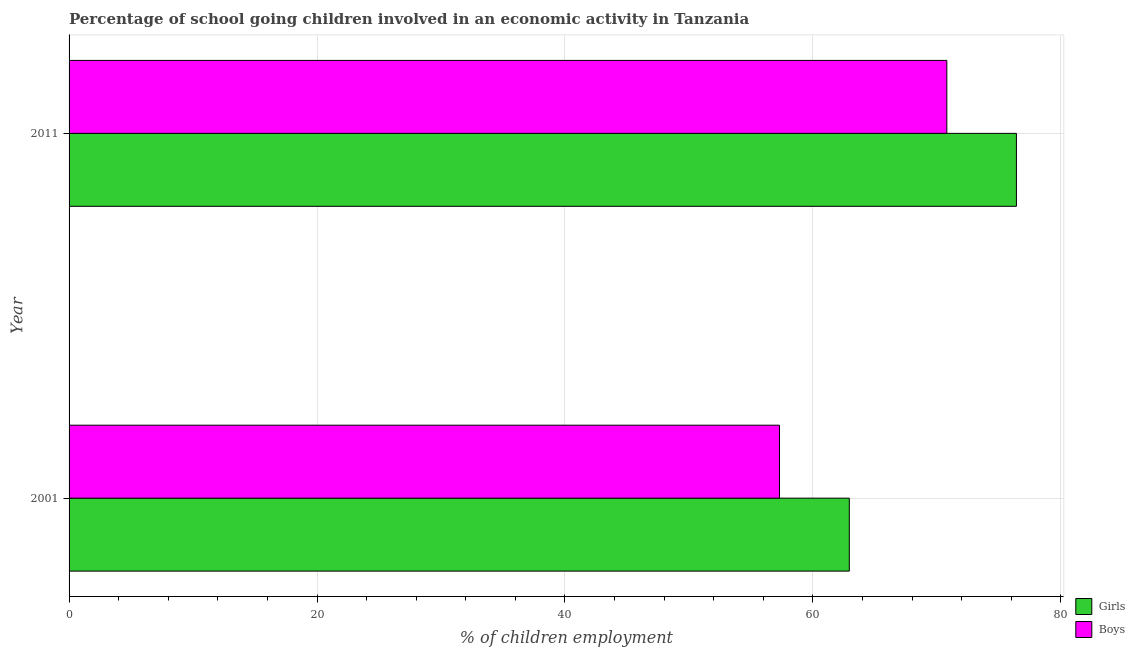Are the number of bars per tick equal to the number of legend labels?
Your response must be concise. Yes. How many bars are there on the 2nd tick from the bottom?
Provide a succinct answer. 2. What is the label of the 1st group of bars from the top?
Offer a terse response. 2011. What is the percentage of school going girls in 2011?
Your response must be concise. 76.41. Across all years, what is the maximum percentage of school going girls?
Offer a very short reply. 76.41. Across all years, what is the minimum percentage of school going boys?
Your response must be concise. 57.3. What is the total percentage of school going girls in the graph?
Offer a terse response. 139.35. What is the difference between the percentage of school going boys in 2001 and that in 2011?
Make the answer very short. -13.5. What is the difference between the percentage of school going boys in 2011 and the percentage of school going girls in 2001?
Keep it short and to the point. 7.87. What is the average percentage of school going boys per year?
Provide a short and direct response. 64.05. In the year 2001, what is the difference between the percentage of school going boys and percentage of school going girls?
Ensure brevity in your answer.  -5.63. In how many years, is the percentage of school going girls greater than 32 %?
Provide a succinct answer. 2. What is the ratio of the percentage of school going girls in 2001 to that in 2011?
Offer a very short reply. 0.82. Is the percentage of school going girls in 2001 less than that in 2011?
Offer a terse response. Yes. Is the difference between the percentage of school going girls in 2001 and 2011 greater than the difference between the percentage of school going boys in 2001 and 2011?
Ensure brevity in your answer.  Yes. What does the 1st bar from the top in 2001 represents?
Keep it short and to the point. Boys. What does the 1st bar from the bottom in 2011 represents?
Your answer should be very brief. Girls. How many bars are there?
Ensure brevity in your answer.  4. Are all the bars in the graph horizontal?
Provide a short and direct response. Yes. How are the legend labels stacked?
Ensure brevity in your answer.  Vertical. What is the title of the graph?
Your response must be concise. Percentage of school going children involved in an economic activity in Tanzania. Does "2012 US$" appear as one of the legend labels in the graph?
Give a very brief answer. No. What is the label or title of the X-axis?
Ensure brevity in your answer.  % of children employment. What is the label or title of the Y-axis?
Offer a very short reply. Year. What is the % of children employment of Girls in 2001?
Provide a succinct answer. 62.93. What is the % of children employment of Boys in 2001?
Your answer should be very brief. 57.3. What is the % of children employment of Girls in 2011?
Your answer should be compact. 76.41. What is the % of children employment of Boys in 2011?
Provide a succinct answer. 70.8. Across all years, what is the maximum % of children employment of Girls?
Provide a short and direct response. 76.41. Across all years, what is the maximum % of children employment of Boys?
Make the answer very short. 70.8. Across all years, what is the minimum % of children employment of Girls?
Your response must be concise. 62.93. Across all years, what is the minimum % of children employment in Boys?
Your response must be concise. 57.3. What is the total % of children employment of Girls in the graph?
Offer a very short reply. 139.35. What is the total % of children employment of Boys in the graph?
Offer a terse response. 128.1. What is the difference between the % of children employment in Girls in 2001 and that in 2011?
Offer a terse response. -13.48. What is the difference between the % of children employment of Boys in 2001 and that in 2011?
Keep it short and to the point. -13.5. What is the difference between the % of children employment in Girls in 2001 and the % of children employment in Boys in 2011?
Ensure brevity in your answer.  -7.87. What is the average % of children employment of Girls per year?
Offer a terse response. 69.67. What is the average % of children employment in Boys per year?
Provide a succinct answer. 64.05. In the year 2001, what is the difference between the % of children employment of Girls and % of children employment of Boys?
Give a very brief answer. 5.63. In the year 2011, what is the difference between the % of children employment of Girls and % of children employment of Boys?
Your answer should be compact. 5.61. What is the ratio of the % of children employment of Girls in 2001 to that in 2011?
Ensure brevity in your answer.  0.82. What is the ratio of the % of children employment of Boys in 2001 to that in 2011?
Offer a terse response. 0.81. What is the difference between the highest and the second highest % of children employment of Girls?
Your response must be concise. 13.48. What is the difference between the highest and the second highest % of children employment of Boys?
Provide a succinct answer. 13.5. What is the difference between the highest and the lowest % of children employment in Girls?
Ensure brevity in your answer.  13.48. What is the difference between the highest and the lowest % of children employment of Boys?
Provide a succinct answer. 13.5. 